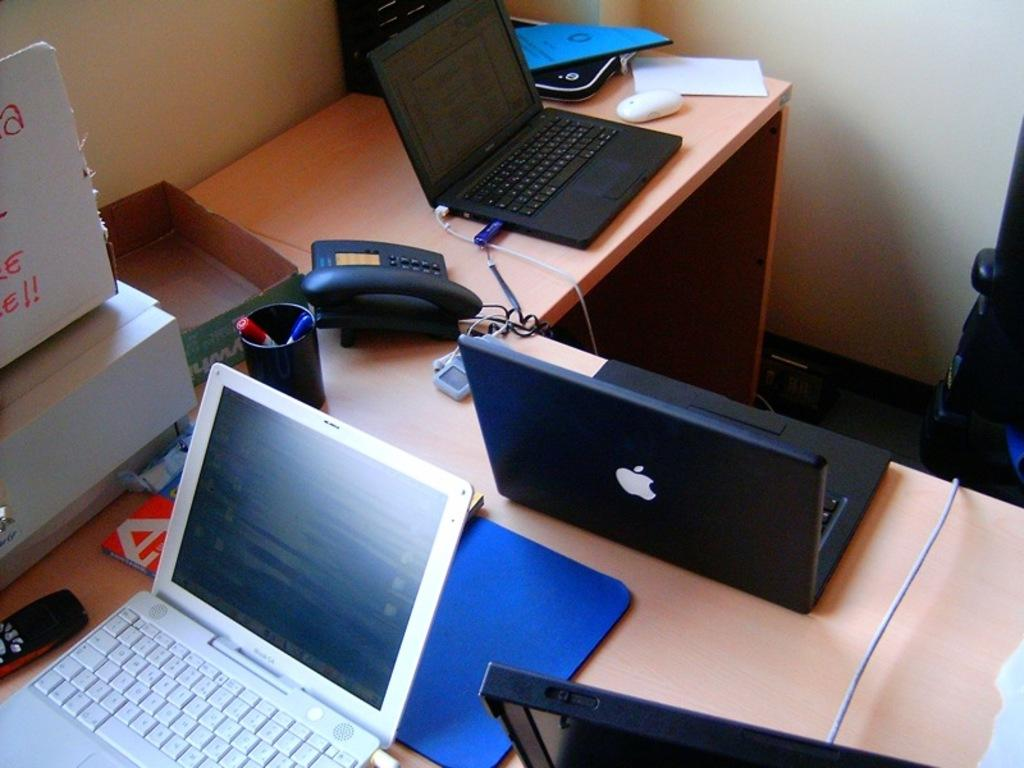How many laptops are visible on the table in the image? There are two laptops on the table. What other objects can be seen on the table? There is a pen stand, a telephone, and some files on the table. What type of brush is used to express an opinion about the laptops in the image? There is no brush present in the image, and opinions cannot be expressed by brushes. 